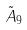<formula> <loc_0><loc_0><loc_500><loc_500>\tilde { A } _ { 9 }</formula> 